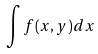Convert formula to latex. <formula><loc_0><loc_0><loc_500><loc_500>\int f ( x , y ) d x</formula> 